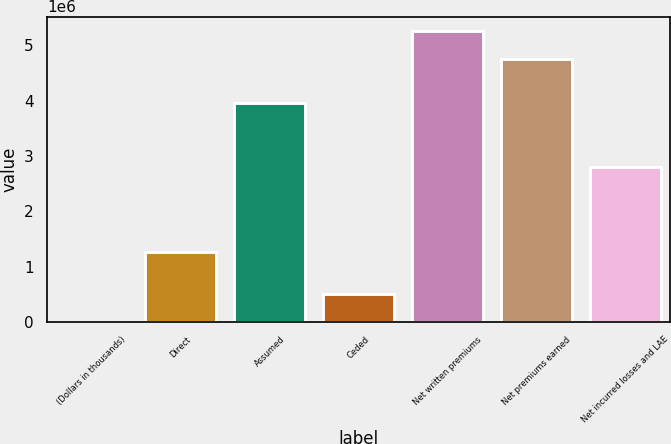<chart> <loc_0><loc_0><loc_500><loc_500><bar_chart><fcel>(Dollars in thousands)<fcel>Direct<fcel>Assumed<fcel>Ceded<fcel>Net written premiums<fcel>Net premiums earned<fcel>Net incurred losses and LAE<nl><fcel>2013<fcel>1.2687e+06<fcel>3.94994e+06<fcel>502294<fcel>5.25382e+06<fcel>4.75354e+06<fcel>2.80025e+06<nl></chart> 